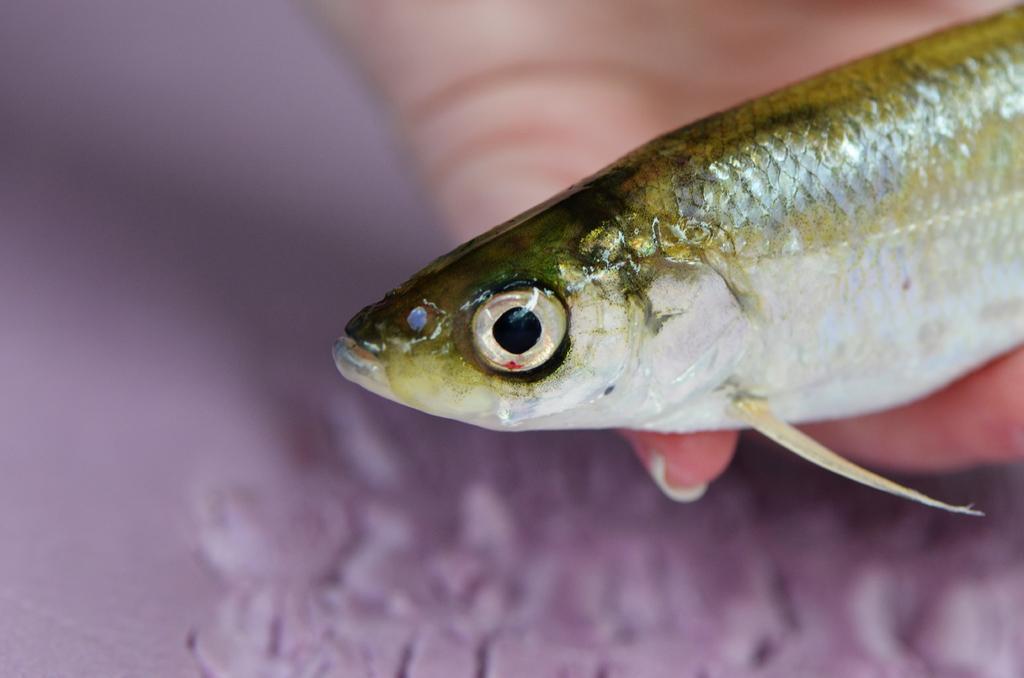Could you give a brief overview of what you see in this image? Here in this picture we can see close up view of a fish present in a hand. 